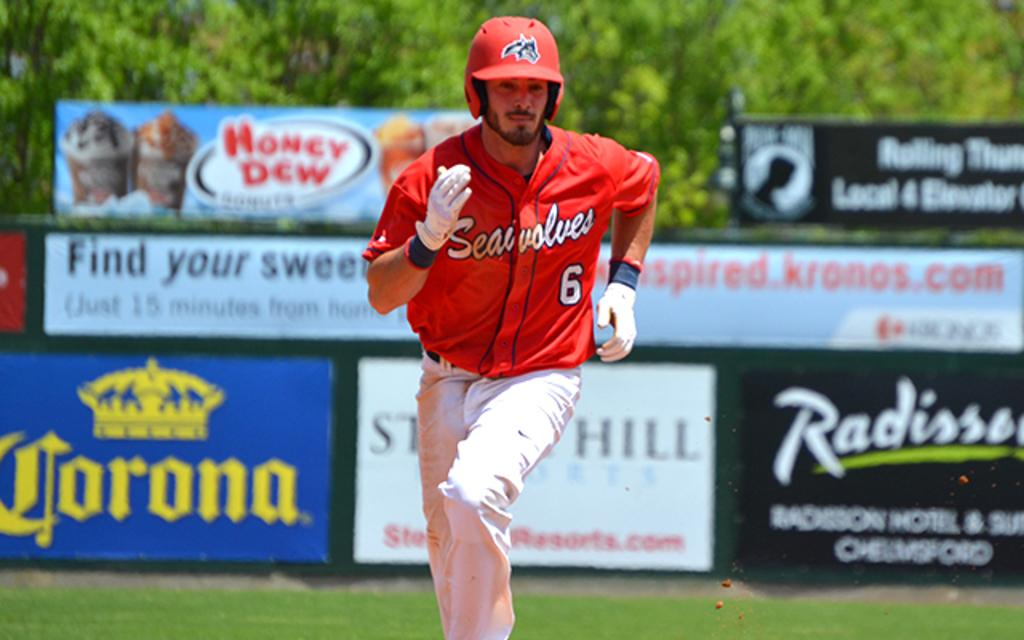Who is the main subject in the image? There is a man in the image. What is the man doing in the image? The man is running. What is the man wearing on his head? The man is wearing a red color helmet. What can be seen in the background of the image? There are posters and green color trees in the background of the image. What type of hook can be seen attached to the man's clothing in the image? There is no hook visible on the man's clothing in the image. What appliance is the man using to run faster in the image? The man is running without any visible appliances in the image. 